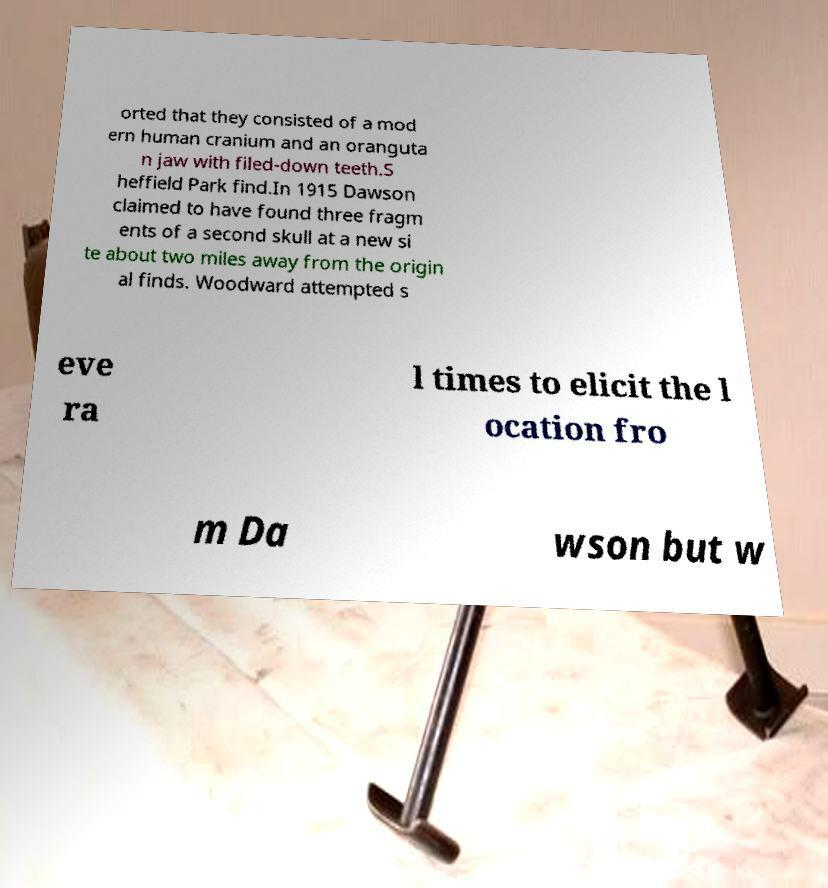Please identify and transcribe the text found in this image. orted that they consisted of a mod ern human cranium and an oranguta n jaw with filed-down teeth.S heffield Park find.In 1915 Dawson claimed to have found three fragm ents of a second skull at a new si te about two miles away from the origin al finds. Woodward attempted s eve ra l times to elicit the l ocation fro m Da wson but w 